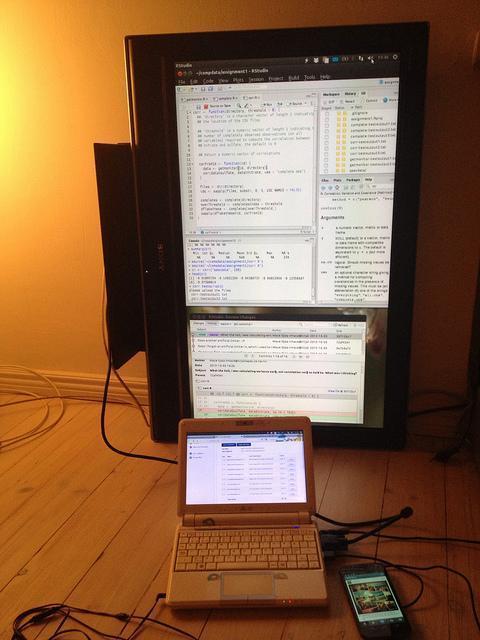How many tvs are in the picture?
Give a very brief answer. 1. How many horses are pulling the buggy?
Give a very brief answer. 0. 